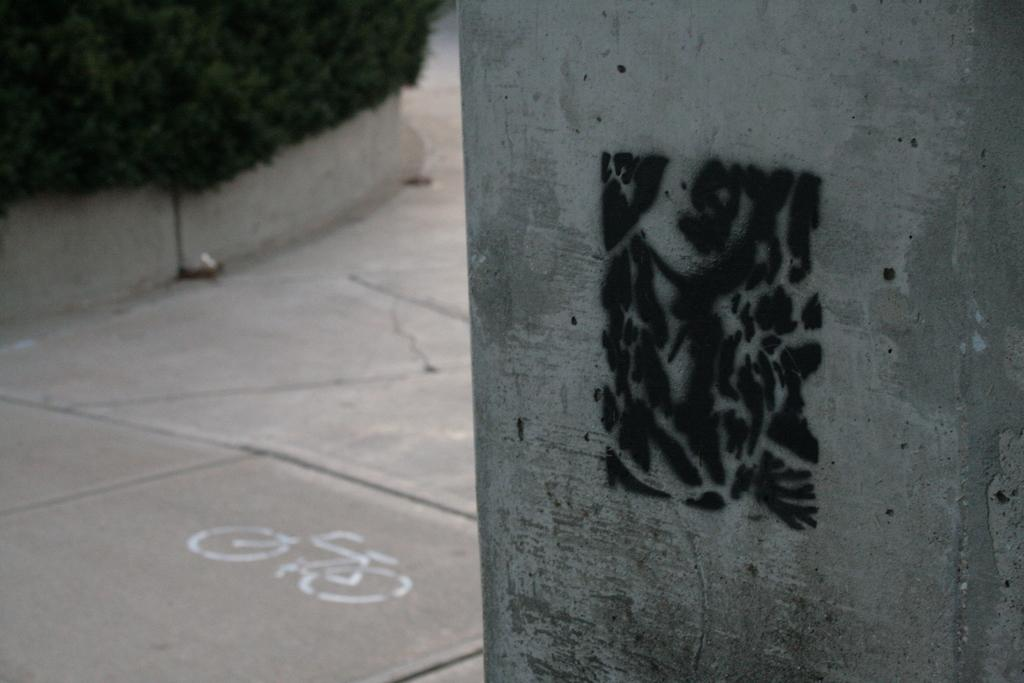What can be seen on the right side of the image? There is a pillar with a painting on the right side of the image. What is located on the left side of the image? There is a walkway on the left side of the image. What type of vegetation is present on the left side of the image? There are plants on the left side of the image. What figure can be found on the path on the left side of the image? There is a bicycle figure on the path on the left side of the image. What word is written on the painting of the pillar in the image? There is no word written on the painting of the pillar in the image; it is a visual representation. What type of meal is being prepared on the walkway in the image? There is no meal being prepared in the image; it features a walkway, plants, and a bicycle figure. 